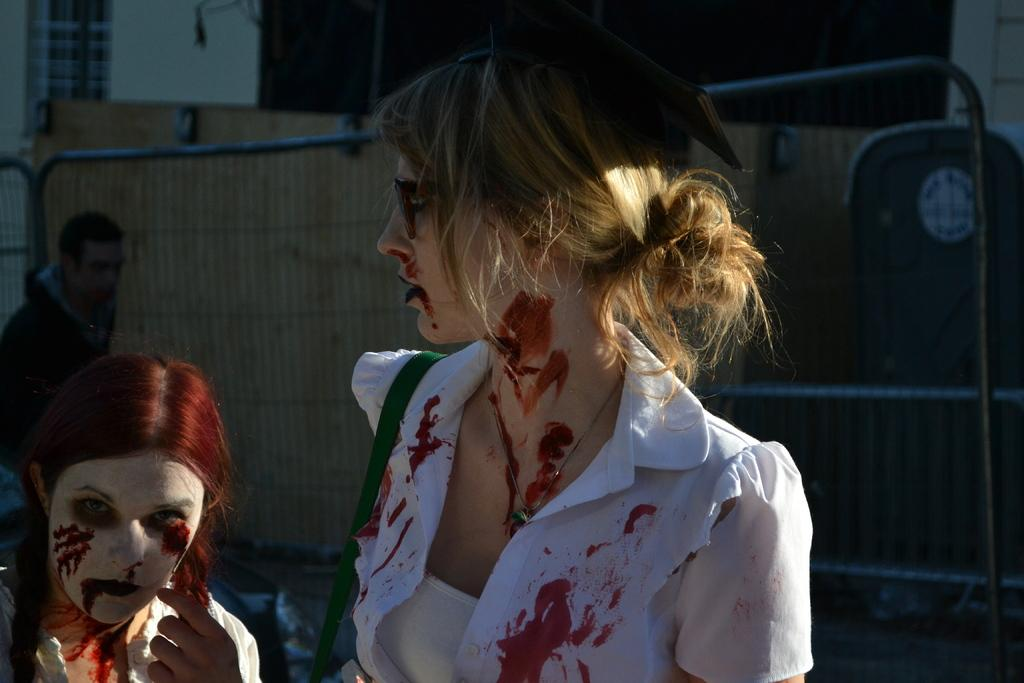What are the two people in the image wearing? The two people in the image are wearing Halloween costumes. What is one of the people holding in the image? One of the people is carrying a bag. Can you describe the background of the image? There is a person, fencing, and a wall visible in the background of the image. What type of trees can be seen in the image? There are no trees visible in the image. 